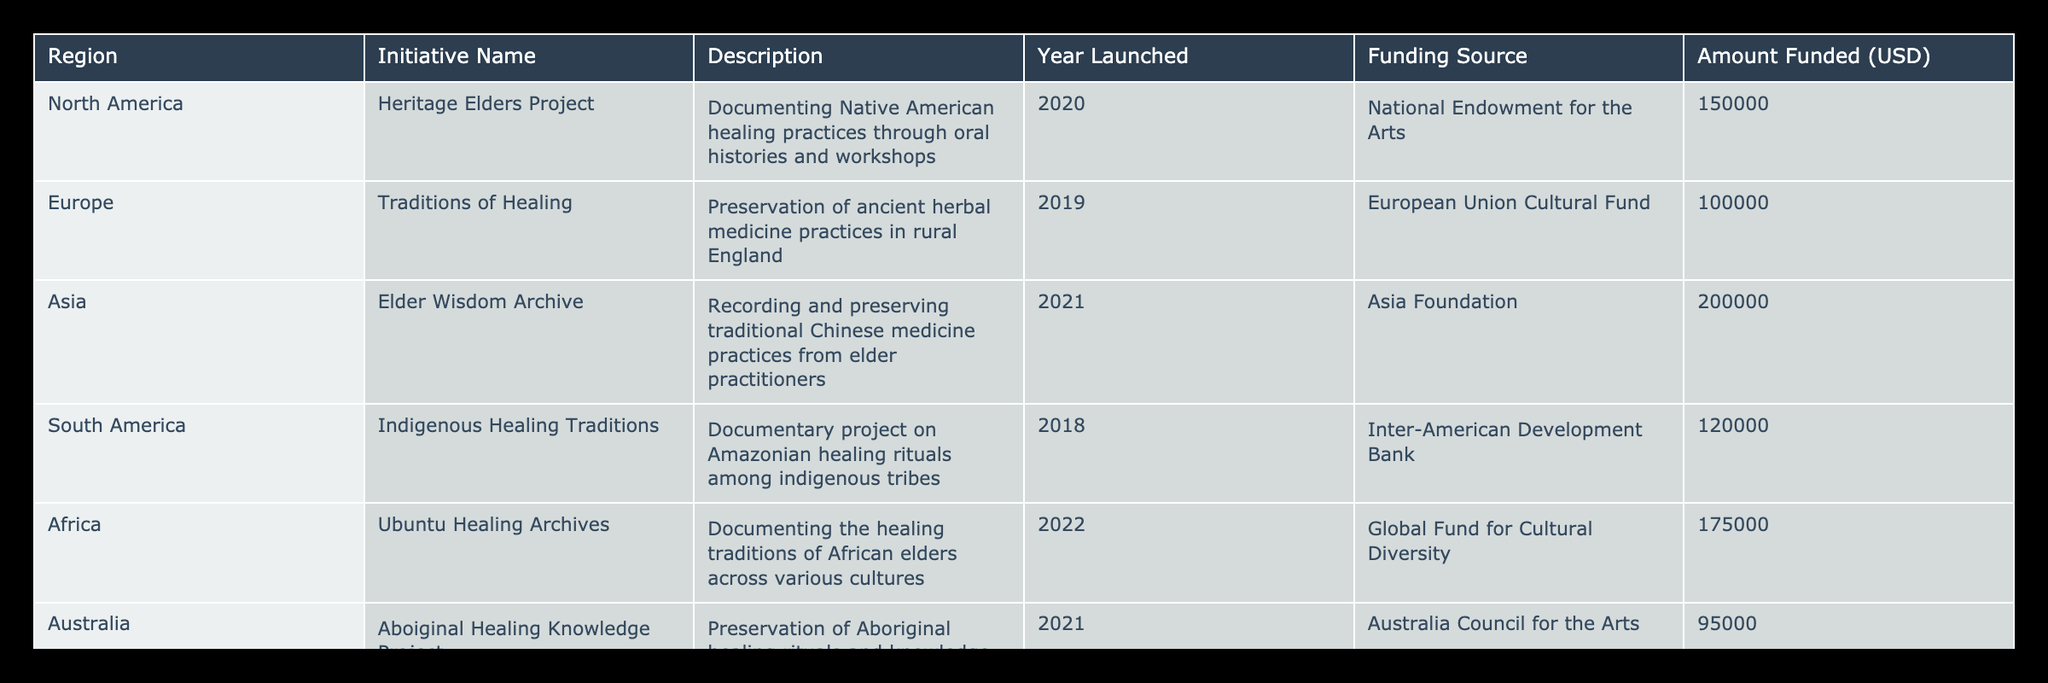What is the initiative name from North America? The table shows a column for initiative names along with their corresponding regions. Looking at the row for North America, the initiative name listed is "Heritage Elders Project."
Answer: Heritage Elders Project Which funding source provided the most money? By examining the "Amount Funded" column, we observe the following values: National Endowment for the Arts (150000), European Union Cultural Fund (100000), Asia Foundation (200000), Inter-American Development Bank (120000), Global Fund for Cultural Diversity (175000), and Australia Council for the Arts (95000). Among these, the Asia Foundation provided the highest amount, which is 200000 USD.
Answer: Asia Foundation What is the total funding amount for all initiatives in the table? To find the total funding, we add the amount funded for each initiative: 150000 + 100000 + 200000 + 120000 + 175000 + 95000. This results in a total of 840000 USD.
Answer: 840000 Is there an initiative in Australia that focuses on healing traditions? The table contains a row for Australia which lists the initiative name as "Aboriginal Healing Knowledge Project." Thus, there is indeed an initiative in Australia that focuses on healing traditions.
Answer: Yes How many initiatives were launched before 2020, and what are their names? We look through the "Year Launched" column to identify which initiatives were launched before 2020. The initiatives launched before 2020 are from Europe (2019) named "Traditions of Healing," South America (2018) named "Indigenous Healing Traditions," and the count of these is 2.
Answer: 2 initiatives: Traditions of Healing, Indigenous Healing Traditions What is the average amount funded across all initiatives listed in this table? We first calculate the total funding amount as previously calculated (840000), then count the number of initiatives, which is 6. To get the average, we divide 840000 by 6, resulting in an average of 140000 USD.
Answer: 140000 Which region has the highest funding for their initiative and how much was it? From the previous analysis, we established that the initiative with the highest funding is from Asia with the Asia Foundation, which provided 200000 USD.
Answer: Asia, 200000 Is the "Elder Wisdom Archive" initiative funded by an organization based in North America? The "Elder Wisdom Archive" has "Asia Foundation" as its funding source, which is not based in North America. Therefore, the answer is no.
Answer: No 